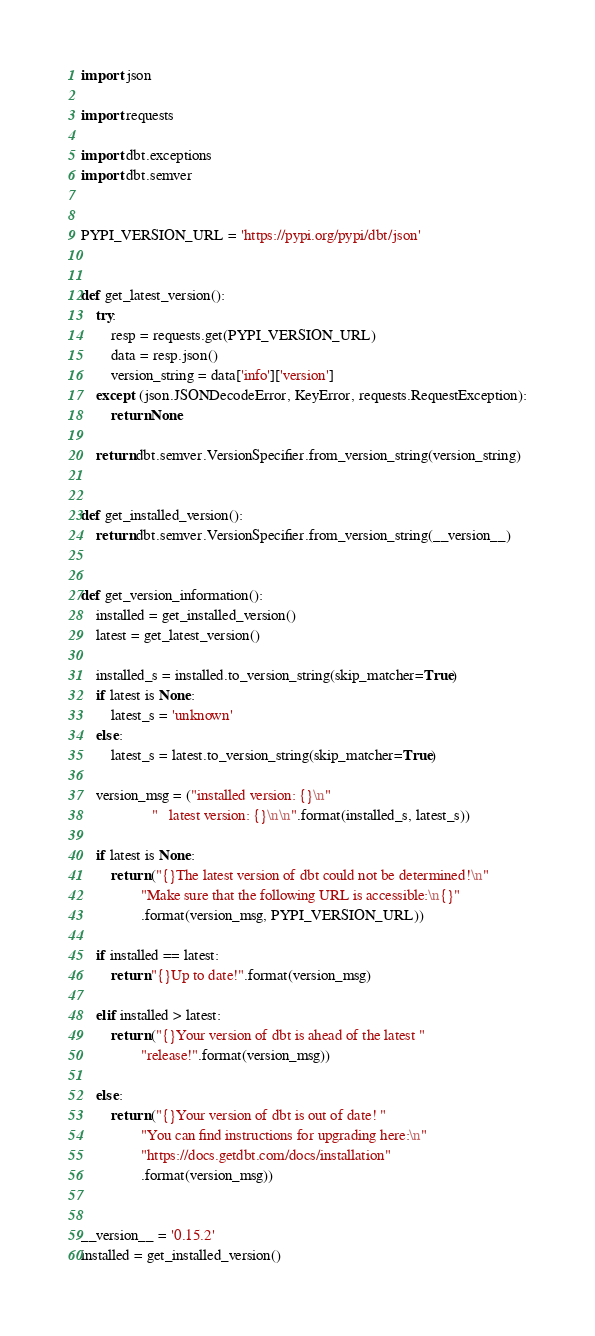<code> <loc_0><loc_0><loc_500><loc_500><_Python_>import json

import requests

import dbt.exceptions
import dbt.semver


PYPI_VERSION_URL = 'https://pypi.org/pypi/dbt/json'


def get_latest_version():
    try:
        resp = requests.get(PYPI_VERSION_URL)
        data = resp.json()
        version_string = data['info']['version']
    except (json.JSONDecodeError, KeyError, requests.RequestException):
        return None

    return dbt.semver.VersionSpecifier.from_version_string(version_string)


def get_installed_version():
    return dbt.semver.VersionSpecifier.from_version_string(__version__)


def get_version_information():
    installed = get_installed_version()
    latest = get_latest_version()

    installed_s = installed.to_version_string(skip_matcher=True)
    if latest is None:
        latest_s = 'unknown'
    else:
        latest_s = latest.to_version_string(skip_matcher=True)

    version_msg = ("installed version: {}\n"
                   "   latest version: {}\n\n".format(installed_s, latest_s))

    if latest is None:
        return ("{}The latest version of dbt could not be determined!\n"
                "Make sure that the following URL is accessible:\n{}"
                .format(version_msg, PYPI_VERSION_URL))

    if installed == latest:
        return "{}Up to date!".format(version_msg)

    elif installed > latest:
        return ("{}Your version of dbt is ahead of the latest "
                "release!".format(version_msg))

    else:
        return ("{}Your version of dbt is out of date! "
                "You can find instructions for upgrading here:\n"
                "https://docs.getdbt.com/docs/installation"
                .format(version_msg))


__version__ = '0.15.2'
installed = get_installed_version()
</code> 